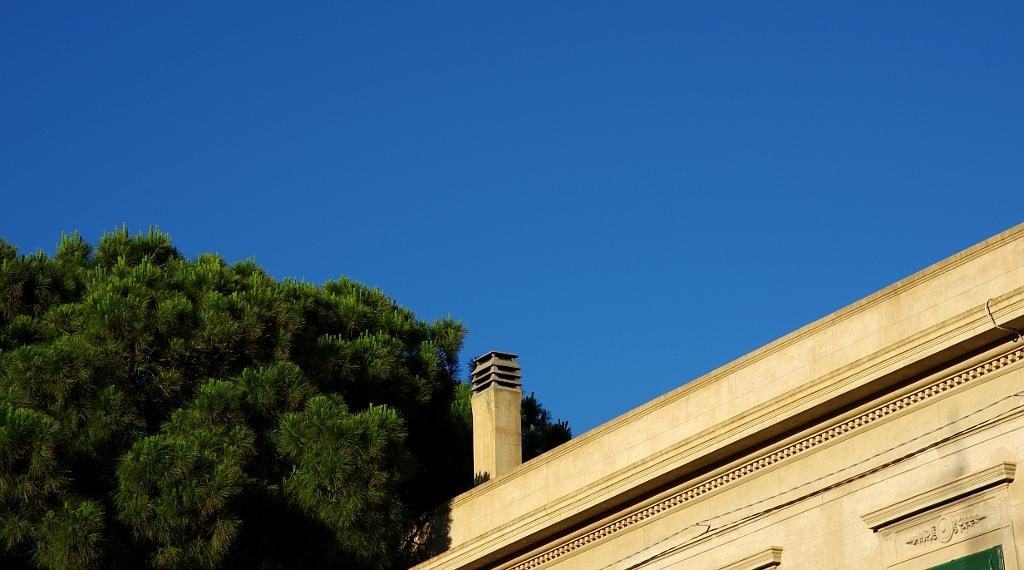What type of structure is present in the image? There is a building in the image. What feature can be seen on the building? The building has windows. What is located on the left side of the image? There is a tree on the left side of the image. What is visible at the top of the image? The sky is visible at the top of the image. What color is the sky in the image? The sky is blue in color. Can you see the mouth of the building in the image? Buildings do not have mouths, so there is no mouth present in the image. Is there a sidewalk in front of the building in the image? The provided facts do not mention a sidewalk, so we cannot determine if one is present in the image. 